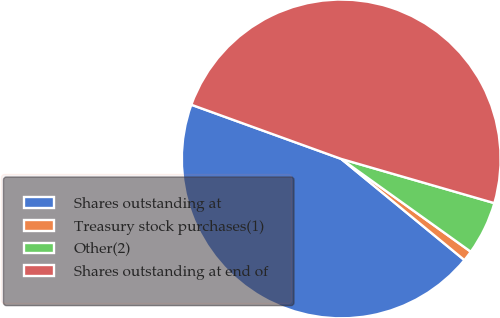<chart> <loc_0><loc_0><loc_500><loc_500><pie_chart><fcel>Shares outstanding at<fcel>Treasury stock purchases(1)<fcel>Other(2)<fcel>Shares outstanding at end of<nl><fcel>44.58%<fcel>1.05%<fcel>5.42%<fcel>48.95%<nl></chart> 